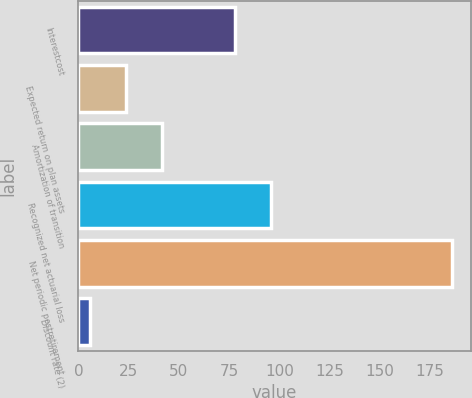<chart> <loc_0><loc_0><loc_500><loc_500><bar_chart><fcel>Interestcost<fcel>Expected return on plan assets<fcel>Amortization of transition<fcel>Recognized net actuarial loss<fcel>Net periodic postretirement<fcel>Discount rate (2)<nl><fcel>78<fcel>23.78<fcel>41.81<fcel>96.03<fcel>186<fcel>5.75<nl></chart> 